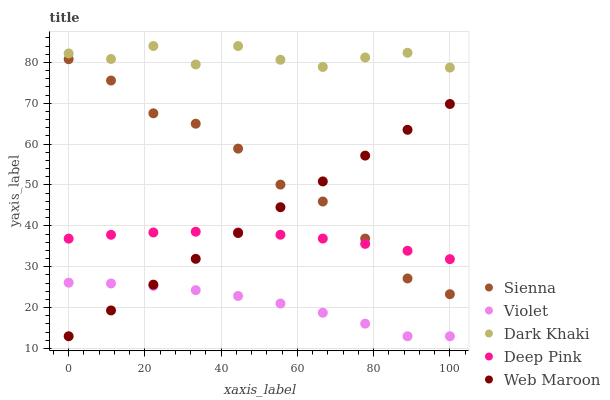Does Violet have the minimum area under the curve?
Answer yes or no. Yes. Does Dark Khaki have the maximum area under the curve?
Answer yes or no. Yes. Does Deep Pink have the minimum area under the curve?
Answer yes or no. No. Does Deep Pink have the maximum area under the curve?
Answer yes or no. No. Is Web Maroon the smoothest?
Answer yes or no. Yes. Is Dark Khaki the roughest?
Answer yes or no. Yes. Is Deep Pink the smoothest?
Answer yes or no. No. Is Deep Pink the roughest?
Answer yes or no. No. Does Web Maroon have the lowest value?
Answer yes or no. Yes. Does Deep Pink have the lowest value?
Answer yes or no. No. Does Dark Khaki have the highest value?
Answer yes or no. Yes. Does Deep Pink have the highest value?
Answer yes or no. No. Is Violet less than Sienna?
Answer yes or no. Yes. Is Dark Khaki greater than Web Maroon?
Answer yes or no. Yes. Does Web Maroon intersect Violet?
Answer yes or no. Yes. Is Web Maroon less than Violet?
Answer yes or no. No. Is Web Maroon greater than Violet?
Answer yes or no. No. Does Violet intersect Sienna?
Answer yes or no. No. 